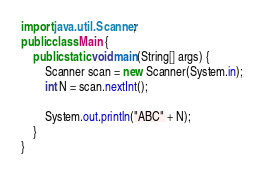<code> <loc_0><loc_0><loc_500><loc_500><_Java_>import java.util.Scanner;
public class Main {
	public static void main(String[] args) {
		Scanner scan = new Scanner(System.in);
		int N = scan.nextInt();
		
		System.out.println("ABC" + N);
	}
}
</code> 